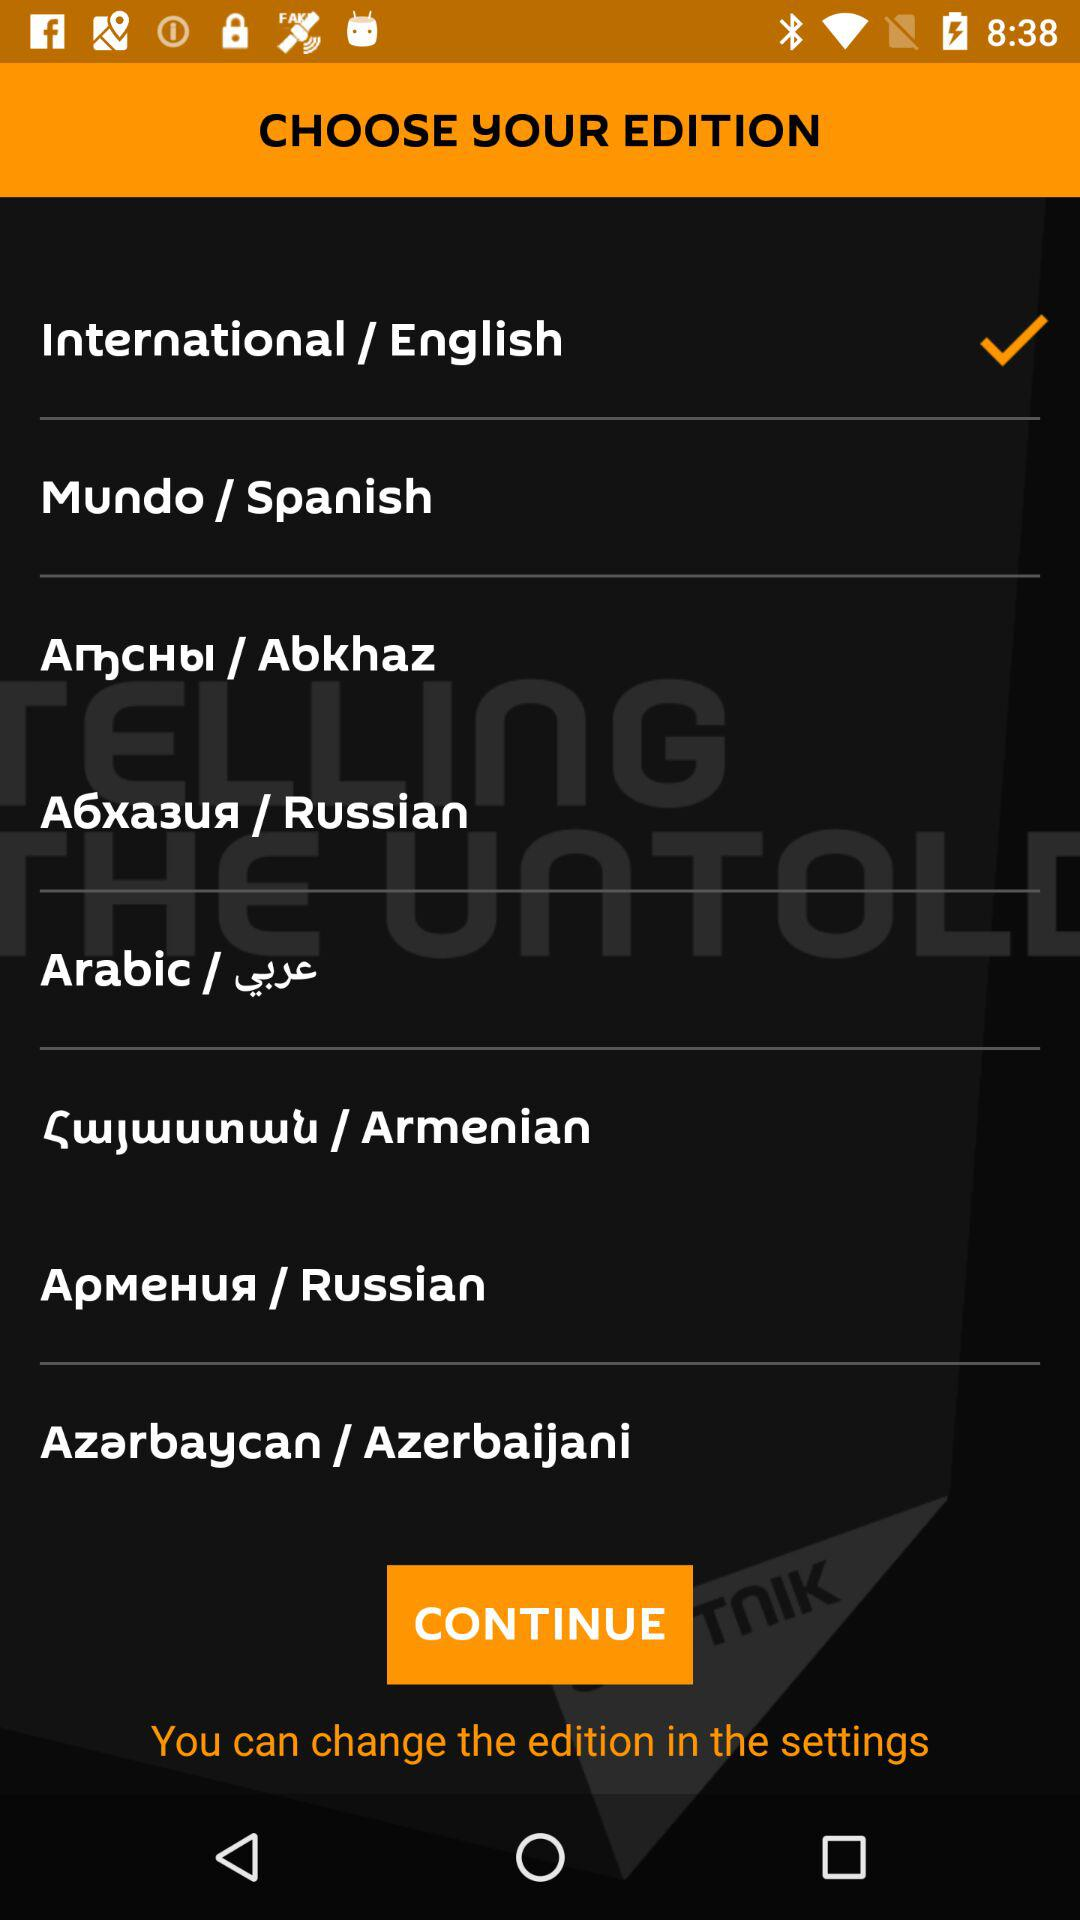How many languages are there to choose from?
Answer the question using a single word or phrase. 8 